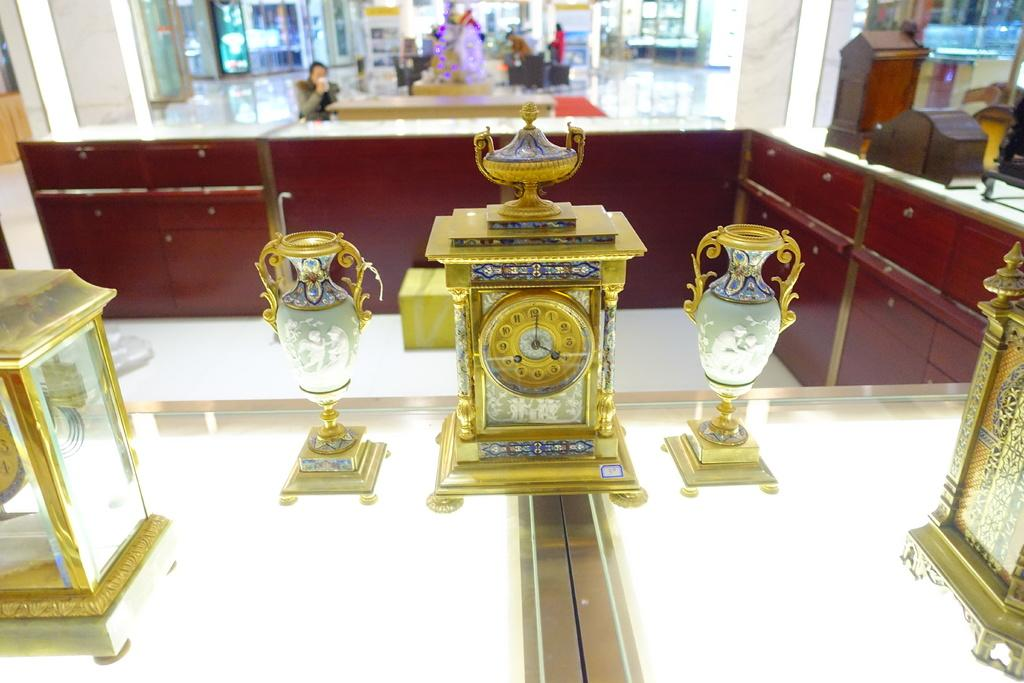What type of space is depicted in the image? The image is of a showroom. What type of furniture can be seen in the showroom? There are cupboards in the showroom. What decorative items are present on a table in the showroom? There are statues on a table in the showroom. Can you describe the table in the background of the showroom? There is a table in the background of the showroom, and a person is drinking at it. How is the showroom illuminated? There are many lights in the showroom. What is one of the walls visible in the showroom? There is a wall visible in the showroom. What type of snail can be seen crawling on the cupboards in the showroom? There are no snails present in the image; the focus is on the cupboards, statues, and other items in the showroom. 